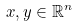<formula> <loc_0><loc_0><loc_500><loc_500>x , y \in \mathbb { R } ^ { n }</formula> 